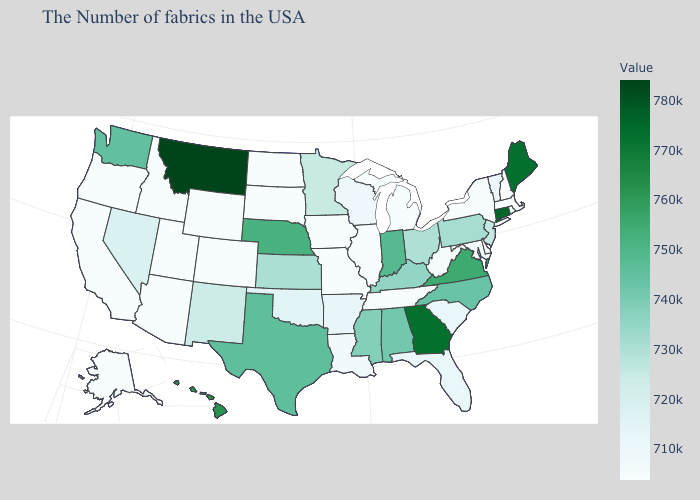Which states have the lowest value in the USA?
Be succinct. Massachusetts, New Hampshire, New York, Delaware, Maryland, Michigan, Tennessee, Illinois, Missouri, Iowa, South Dakota, North Dakota, Wyoming, Colorado, Utah, Arizona, Idaho, California, Oregon, Alaska. Which states have the lowest value in the South?
Quick response, please. Delaware, Maryland, Tennessee. Among the states that border Utah , does Idaho have the highest value?
Write a very short answer. No. Which states have the highest value in the USA?
Write a very short answer. Montana. Among the states that border Connecticut , which have the highest value?
Short answer required. Rhode Island. Does New Mexico have a higher value than Massachusetts?
Answer briefly. Yes. Which states have the lowest value in the USA?
Answer briefly. Massachusetts, New Hampshire, New York, Delaware, Maryland, Michigan, Tennessee, Illinois, Missouri, Iowa, South Dakota, North Dakota, Wyoming, Colorado, Utah, Arizona, Idaho, California, Oregon, Alaska. Does Michigan have the highest value in the USA?
Answer briefly. No. 